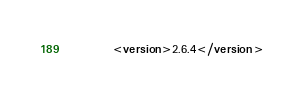Convert code to text. <code><loc_0><loc_0><loc_500><loc_500><_XML_>		<version>2.6.4</version></code> 